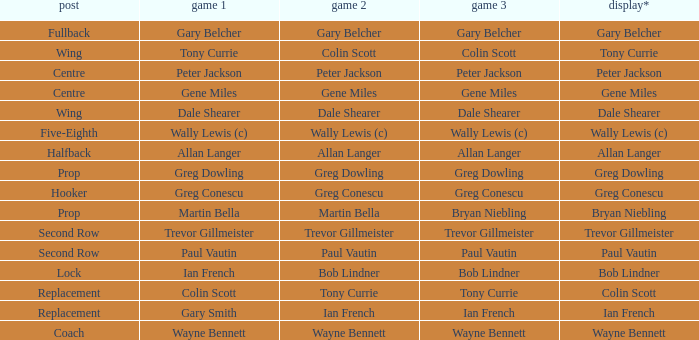What game 1 has bob lindner as game 2? Ian French. 